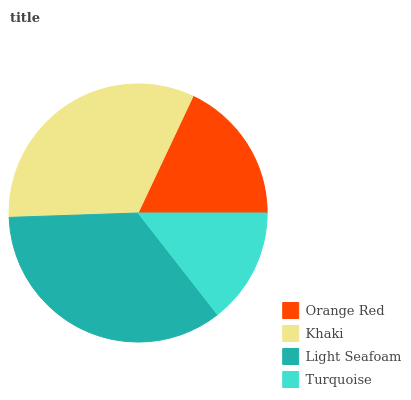Is Turquoise the minimum?
Answer yes or no. Yes. Is Light Seafoam the maximum?
Answer yes or no. Yes. Is Khaki the minimum?
Answer yes or no. No. Is Khaki the maximum?
Answer yes or no. No. Is Khaki greater than Orange Red?
Answer yes or no. Yes. Is Orange Red less than Khaki?
Answer yes or no. Yes. Is Orange Red greater than Khaki?
Answer yes or no. No. Is Khaki less than Orange Red?
Answer yes or no. No. Is Khaki the high median?
Answer yes or no. Yes. Is Orange Red the low median?
Answer yes or no. Yes. Is Orange Red the high median?
Answer yes or no. No. Is Turquoise the low median?
Answer yes or no. No. 